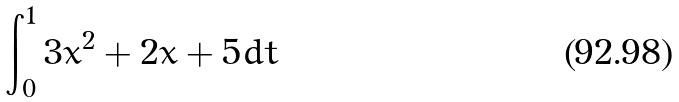Convert formula to latex. <formula><loc_0><loc_0><loc_500><loc_500>\int _ { 0 } ^ { 1 } 3 x ^ { 2 } + 2 x + 5 d t</formula> 